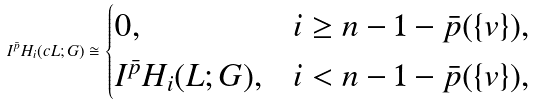Convert formula to latex. <formula><loc_0><loc_0><loc_500><loc_500>I ^ { \bar { p } } H _ { i } ( c L ; G ) \cong \begin{cases} 0 , & i \geq n - 1 - \bar { p } ( \{ v \} ) , \\ I ^ { \bar { p } } H _ { i } ( L ; G ) , & i < n - 1 - \bar { p } ( \{ v \} ) , \end{cases}</formula> 